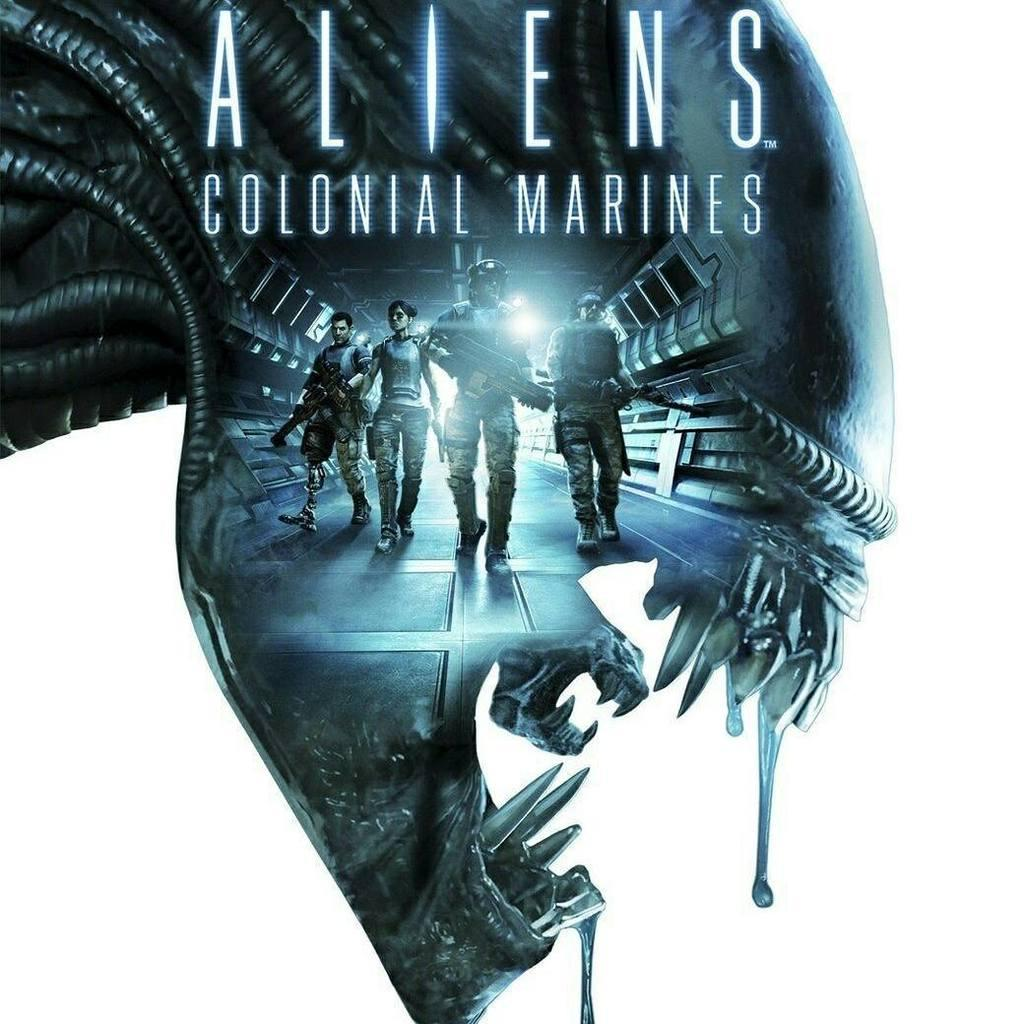<image>
Share a concise interpretation of the image provided. Poster showing four soldiers titled Aliens Colonial Marines. 